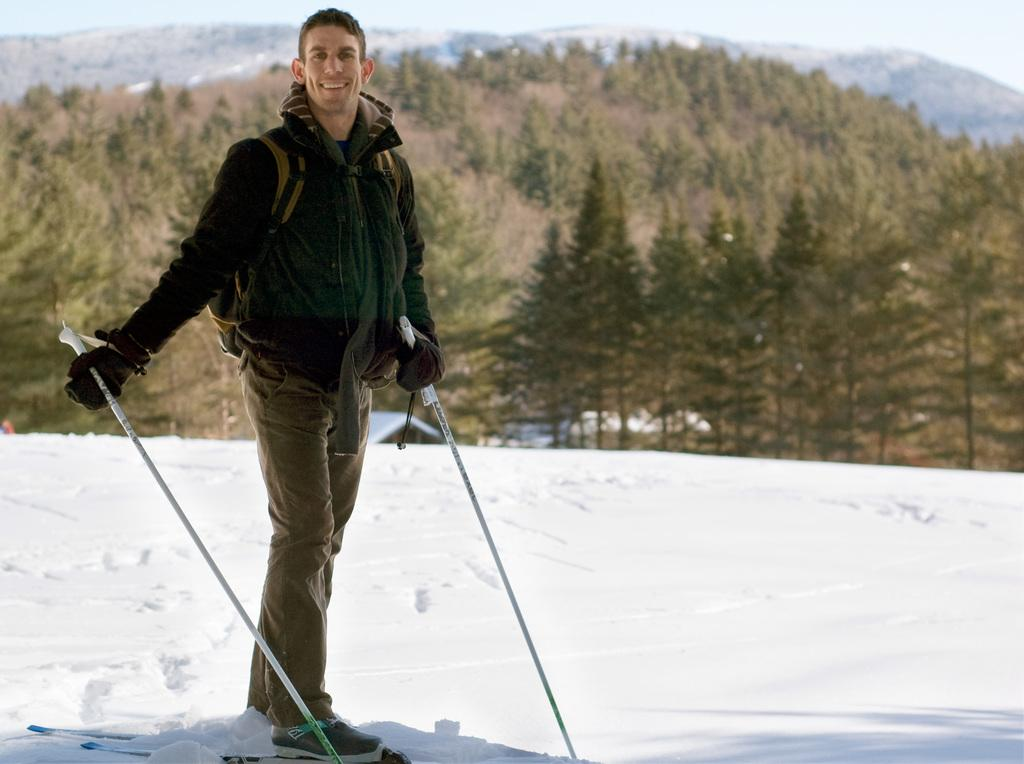What is the main subject of the image? There is a man in the image. What is the man doing in the image? The man is standing on a ski board. What type of terrain is visible at the bottom of the image? There is snow at the bottom of the image. What can be seen in the background of the image? There are trees, hills, and the sky visible in the background of the image. What type of substance is the rat holding in the image? There is no rat present in the image, so it is not possible to determine what substance the rat might be holding. 